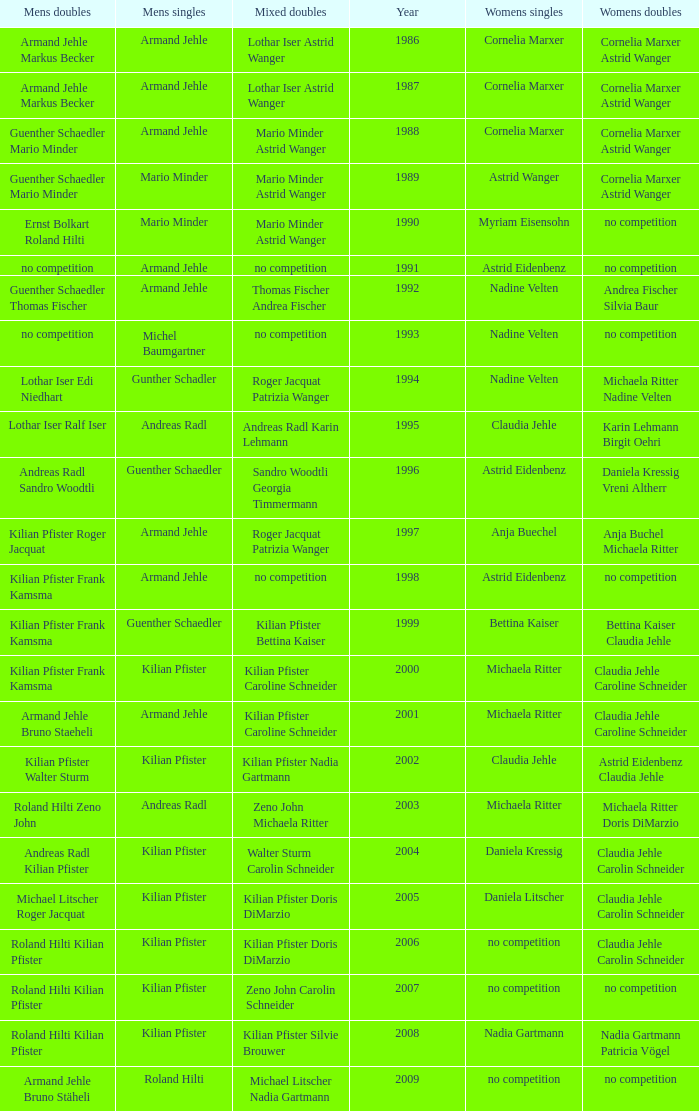In the year 2006, the womens singles had no competition and the mens doubles were roland hilti kilian pfister, what were the womens doubles Claudia Jehle Carolin Schneider. 